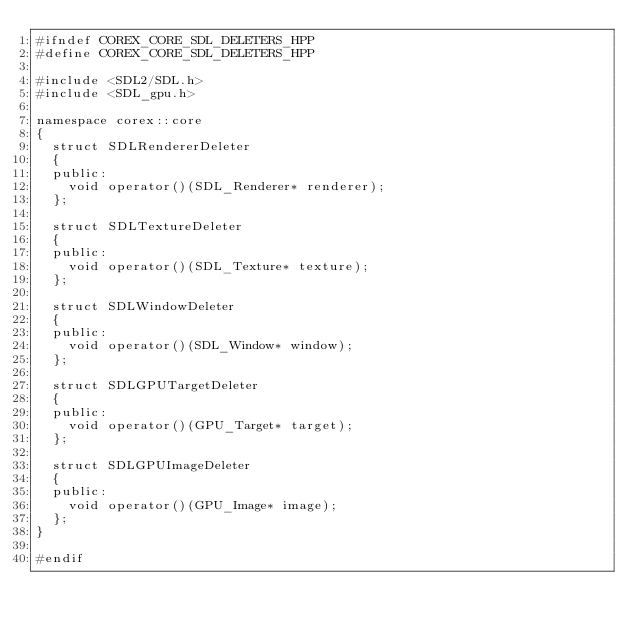Convert code to text. <code><loc_0><loc_0><loc_500><loc_500><_C++_>#ifndef COREX_CORE_SDL_DELETERS_HPP
#define COREX_CORE_SDL_DELETERS_HPP

#include <SDL2/SDL.h>
#include <SDL_gpu.h>

namespace corex::core
{
  struct SDLRendererDeleter
  {
  public:
    void operator()(SDL_Renderer* renderer);
  };

  struct SDLTextureDeleter
  {
  public:
    void operator()(SDL_Texture* texture);
  };

  struct SDLWindowDeleter
  {
  public:
    void operator()(SDL_Window* window);
  };

  struct SDLGPUTargetDeleter
  {
  public:
    void operator()(GPU_Target* target);
  };

  struct SDLGPUImageDeleter
  {
  public:
    void operator()(GPU_Image* image);
  };
}

#endif
</code> 